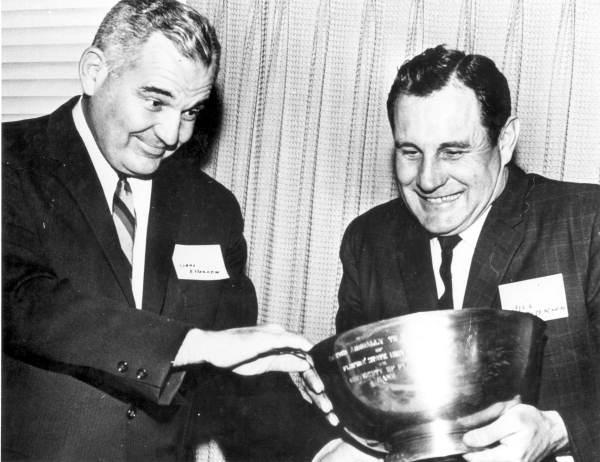What are the gentlemen holding?
Be succinct. Bowl. Is this bowl functional or ornamental?
Write a very short answer. Ornamental. What ethnicity are the people in the picture?
Keep it brief. White. 